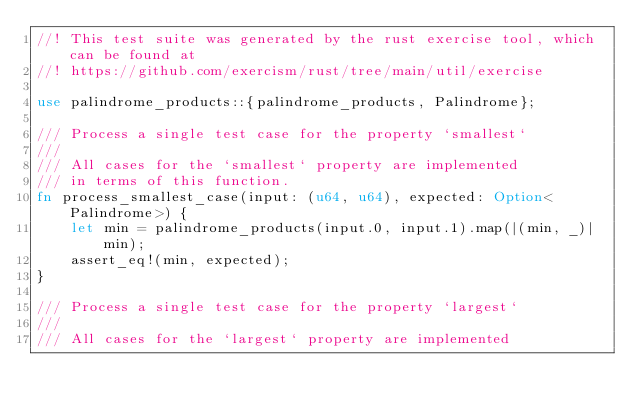<code> <loc_0><loc_0><loc_500><loc_500><_Rust_>//! This test suite was generated by the rust exercise tool, which can be found at
//! https://github.com/exercism/rust/tree/main/util/exercise

use palindrome_products::{palindrome_products, Palindrome};

/// Process a single test case for the property `smallest`
///
/// All cases for the `smallest` property are implemented
/// in terms of this function.
fn process_smallest_case(input: (u64, u64), expected: Option<Palindrome>) {
    let min = palindrome_products(input.0, input.1).map(|(min, _)| min);
    assert_eq!(min, expected);
}

/// Process a single test case for the property `largest`
///
/// All cases for the `largest` property are implemented</code> 